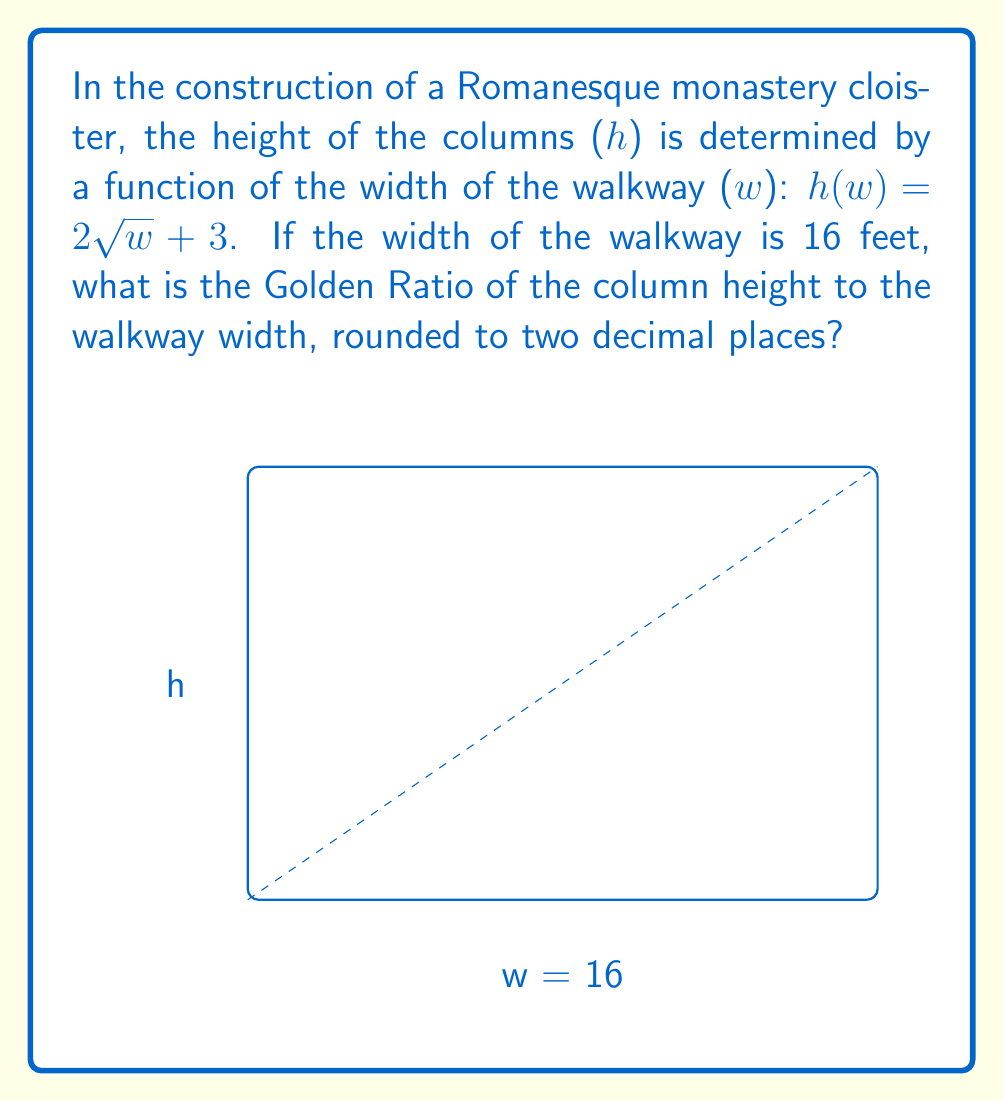Solve this math problem. To solve this problem, we'll follow these steps:

1. Calculate the height of the column using the given function:
   $h(w) = 2\sqrt{w} + 3$
   $h(16) = 2\sqrt{16} + 3$
   $h(16) = 2(4) + 3 = 11$ feet

2. Recall that the Golden Ratio is approximately 1.618 and is calculated as:
   $\frac{a+b}{a} = \frac{a}{b}$, where $a$ is the larger value and $b$ is the smaller value.

3. In our case, $a = 16$ (walkway width) and $b = 11$ (column height).

4. Calculate the ratio:
   $\frac{16+11}{16} = \frac{27}{16} = 1.6875$

5. Round the result to two decimal places: 1.69

This ratio closely approximates the Golden Ratio, demonstrating the harmonious proportions often found in monastic architecture.
Answer: 1.69 